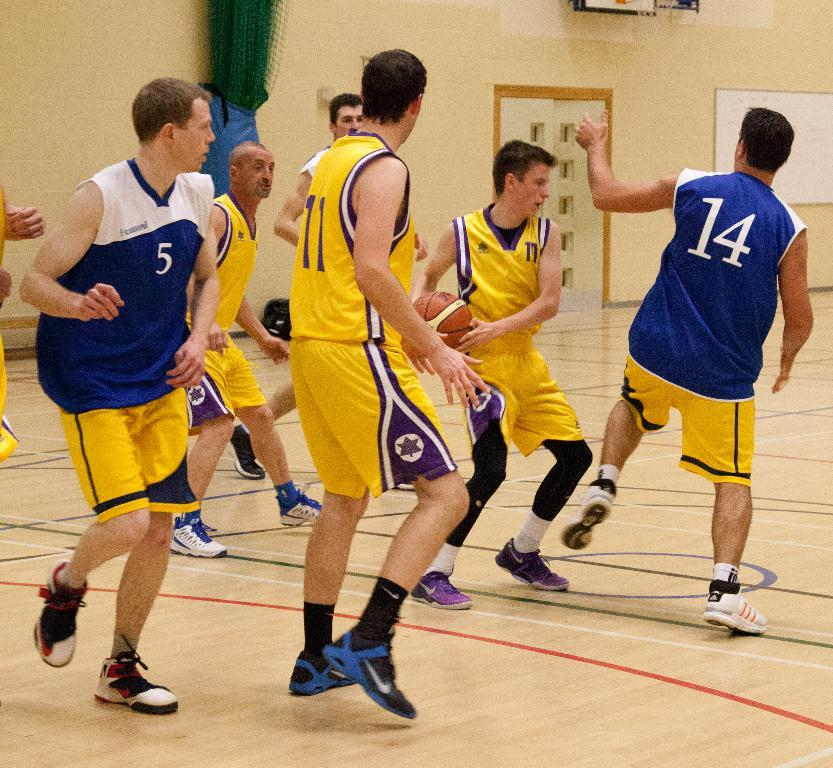<image>
Create a compact narrative representing the image presented. basketball players playing on a court with the numbers 11, 14 and 5 